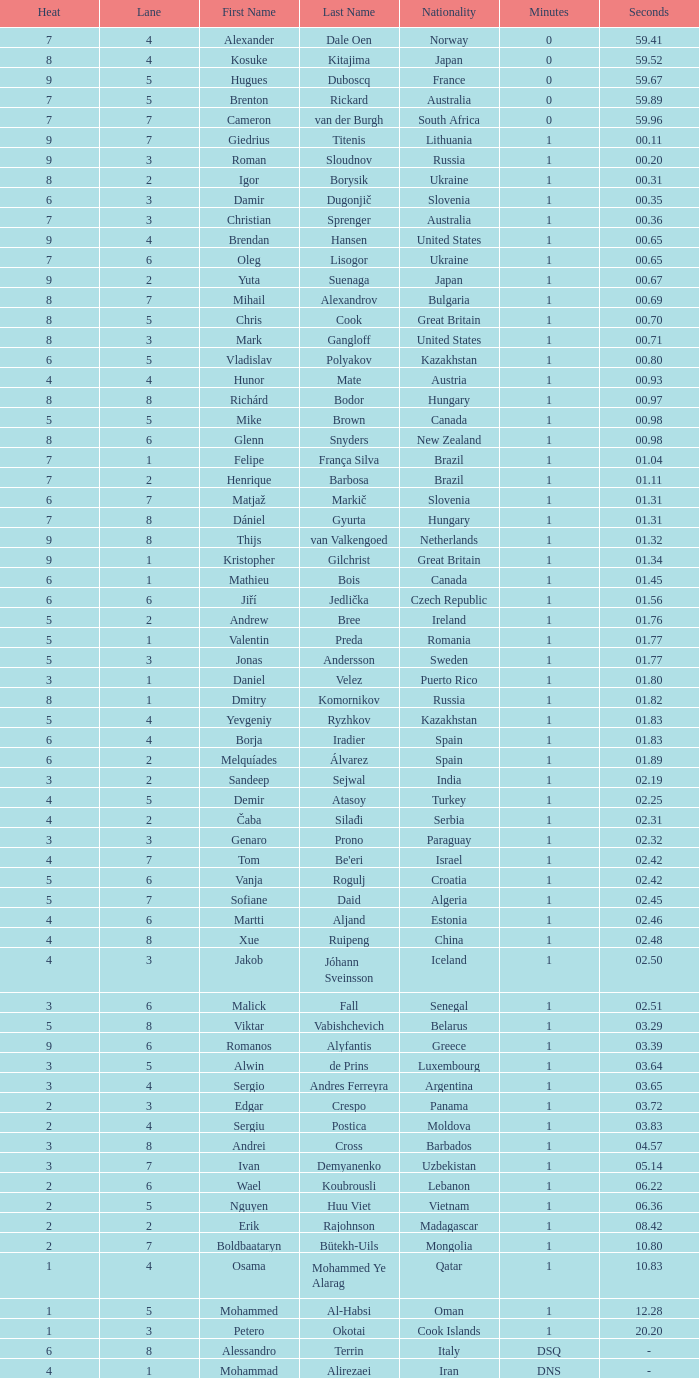What is the smallest lane number of Xue Ruipeng? 8.0. 